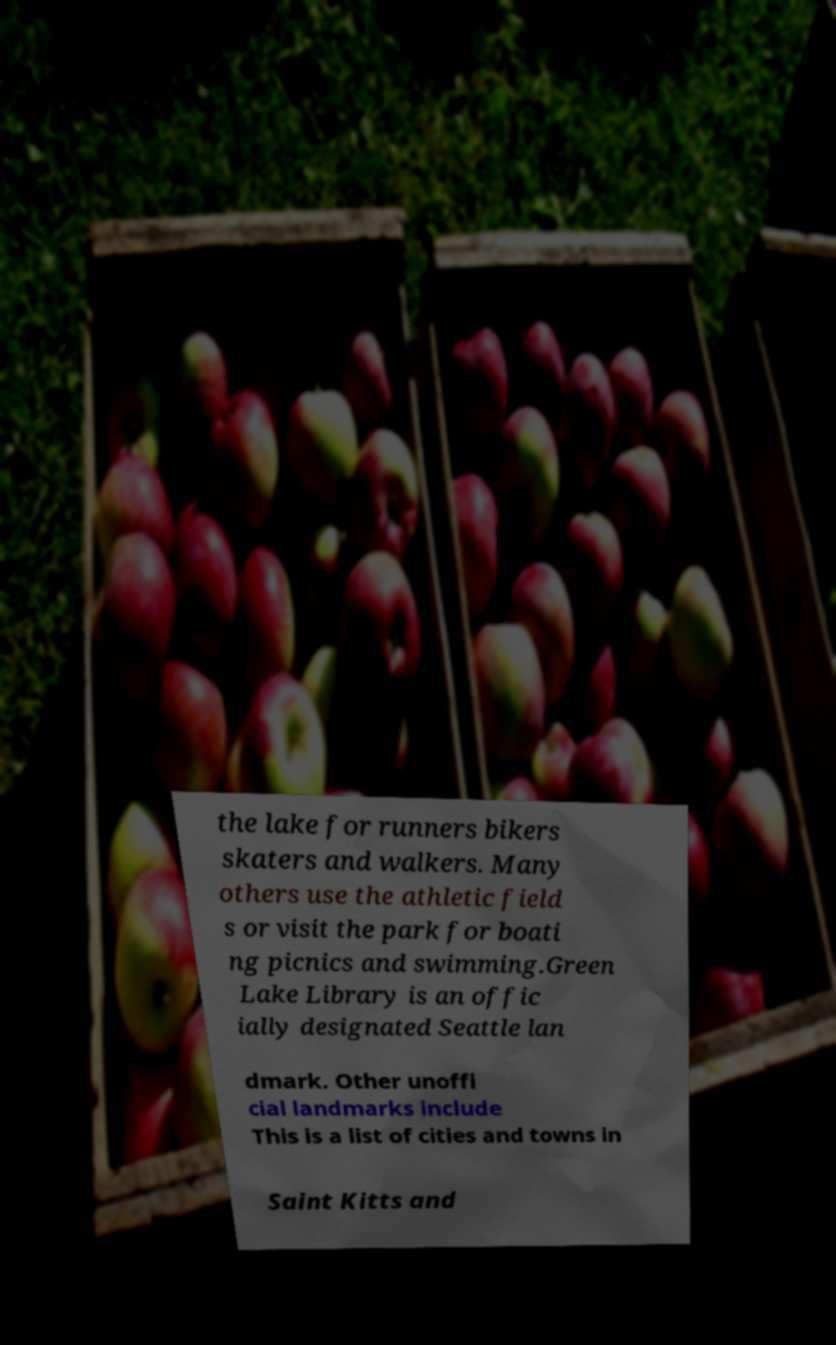Can you read and provide the text displayed in the image?This photo seems to have some interesting text. Can you extract and type it out for me? the lake for runners bikers skaters and walkers. Many others use the athletic field s or visit the park for boati ng picnics and swimming.Green Lake Library is an offic ially designated Seattle lan dmark. Other unoffi cial landmarks include This is a list of cities and towns in Saint Kitts and 